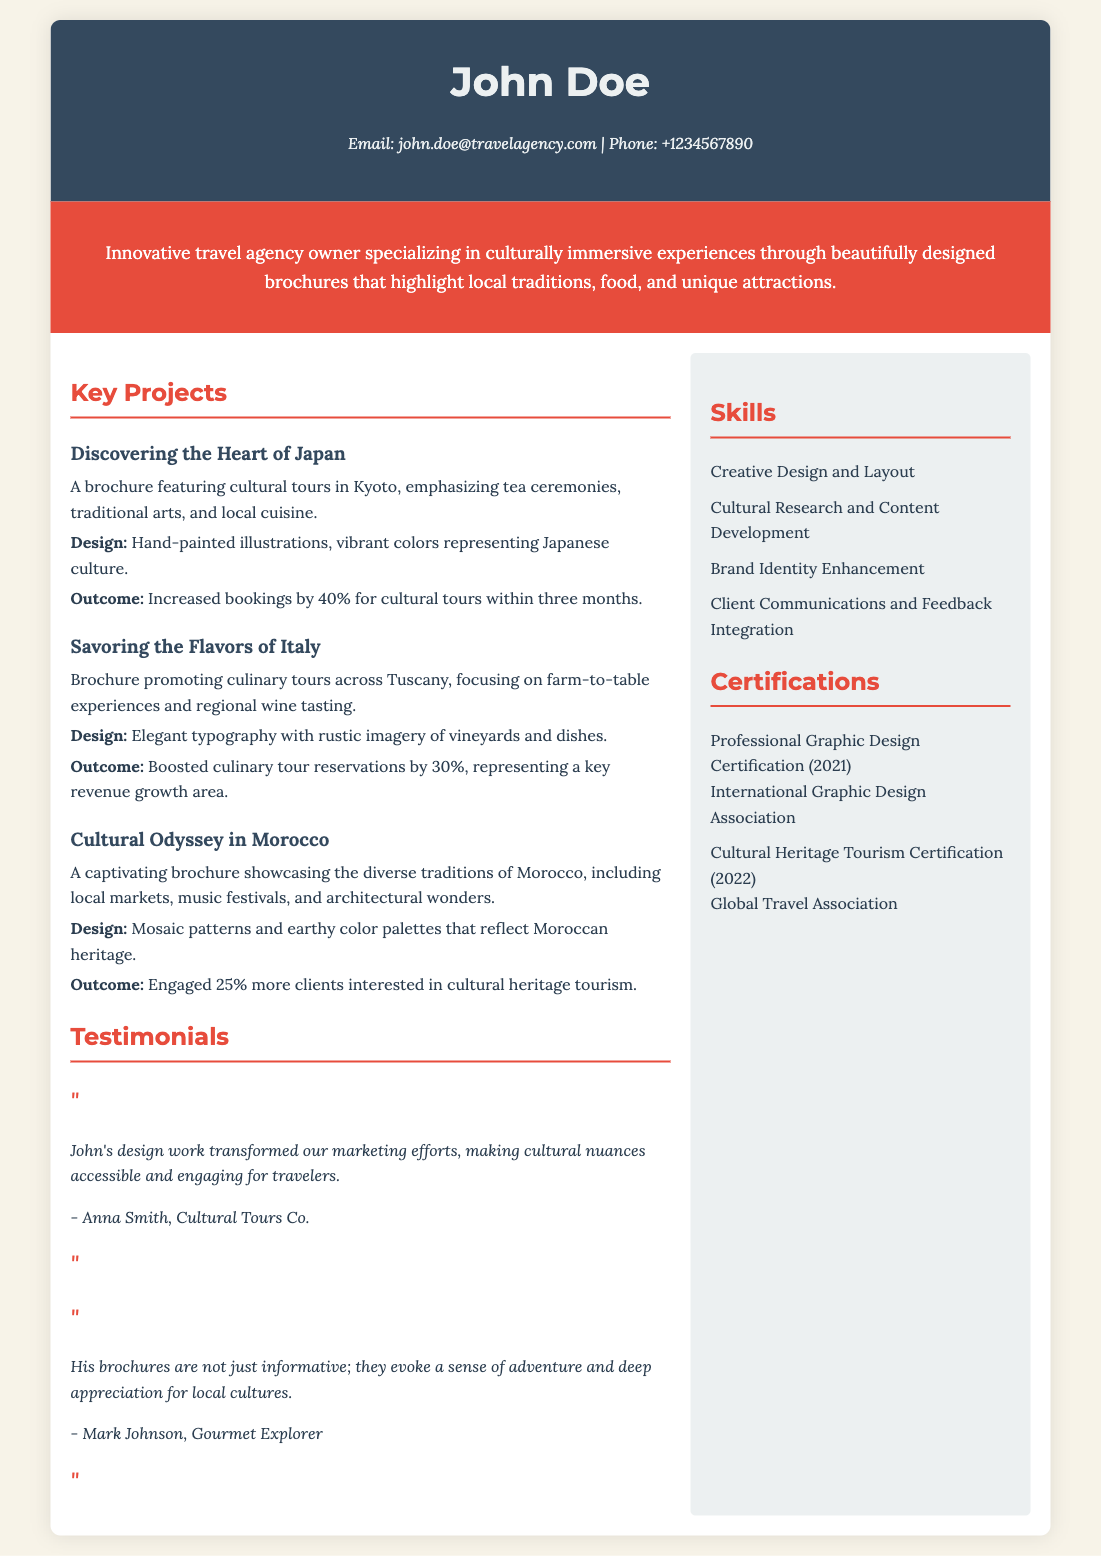What is the name of the designer? The designer's name is mentioned at the top of the document in the header.
Answer: John Doe What is the contact email provided? The email is included in the contact information section.
Answer: john.doe@travelagency.com How much did bookings increase for cultural tours in Japan? The increase is stated in the outcome section of that project.
Answer: 40% What style of imagery was used in the Italy brochure? This detail is found in the design description of that project.
Answer: Rustic imagery What year was the Professional Graphic Design Certification obtained? The certification's year is mentioned in the certifications section.
Answer: 2021 Which project engaged 25% more clients? The specific project is identified in the description of the Moroccan brochure.
Answer: Cultural Odyssey in Morocco Who provided a testimonial about John's design work? The testimonial section lists names of people who provided feedback.
Answer: Anna Smith What skills are listed in the skills section? The skills mentioned give insights into the designer's capabilities.
Answer: Creative Design and Layout What was the focus of the brochure “Savoring the Flavors of Italy”? The focus is indicated in the description of that project.
Answer: Culinary tours across Tuscany 